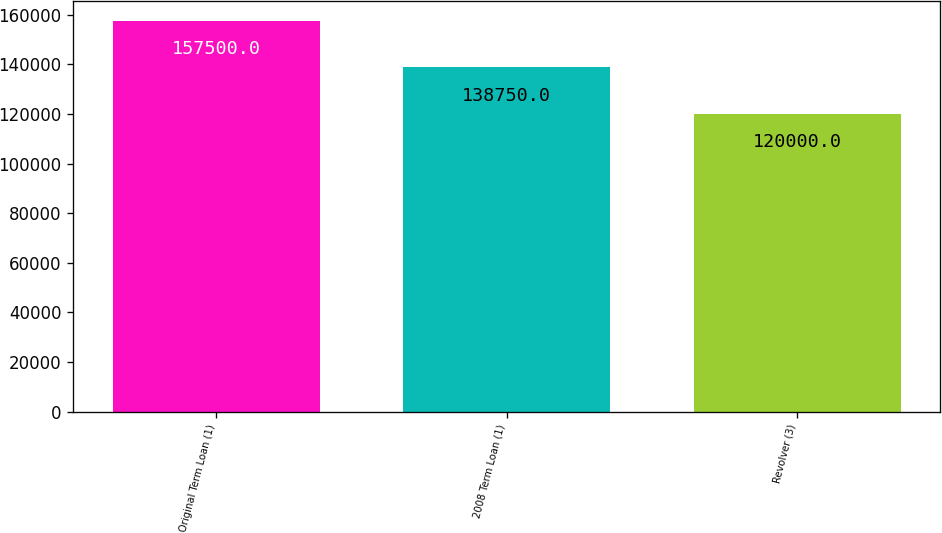Convert chart. <chart><loc_0><loc_0><loc_500><loc_500><bar_chart><fcel>Original Term Loan (1)<fcel>2008 Term Loan (1)<fcel>Revolver (3)<nl><fcel>157500<fcel>138750<fcel>120000<nl></chart> 